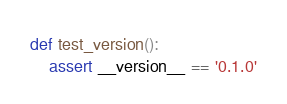<code> <loc_0><loc_0><loc_500><loc_500><_Python_>

def test_version():
    assert __version__ == '0.1.0'
</code> 